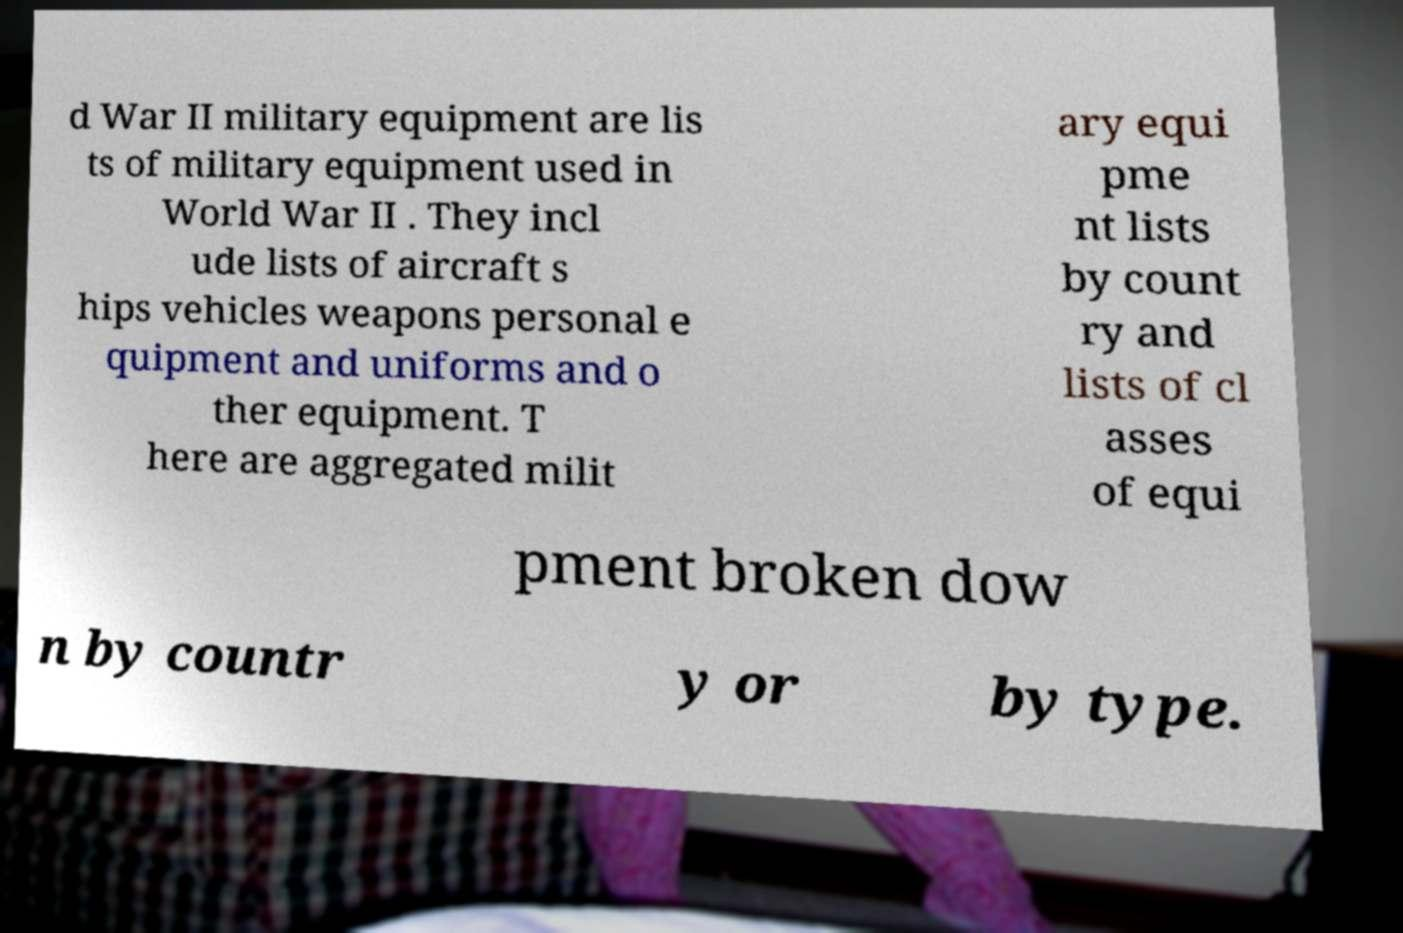I need the written content from this picture converted into text. Can you do that? d War II military equipment are lis ts of military equipment used in World War II . They incl ude lists of aircraft s hips vehicles weapons personal e quipment and uniforms and o ther equipment. T here are aggregated milit ary equi pme nt lists by count ry and lists of cl asses of equi pment broken dow n by countr y or by type. 